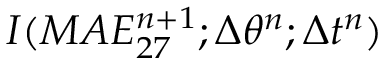Convert formula to latex. <formula><loc_0><loc_0><loc_500><loc_500>I ( M A E _ { 2 7 } ^ { n + 1 } ; \Delta \theta ^ { n } ; \Delta t ^ { n } )</formula> 